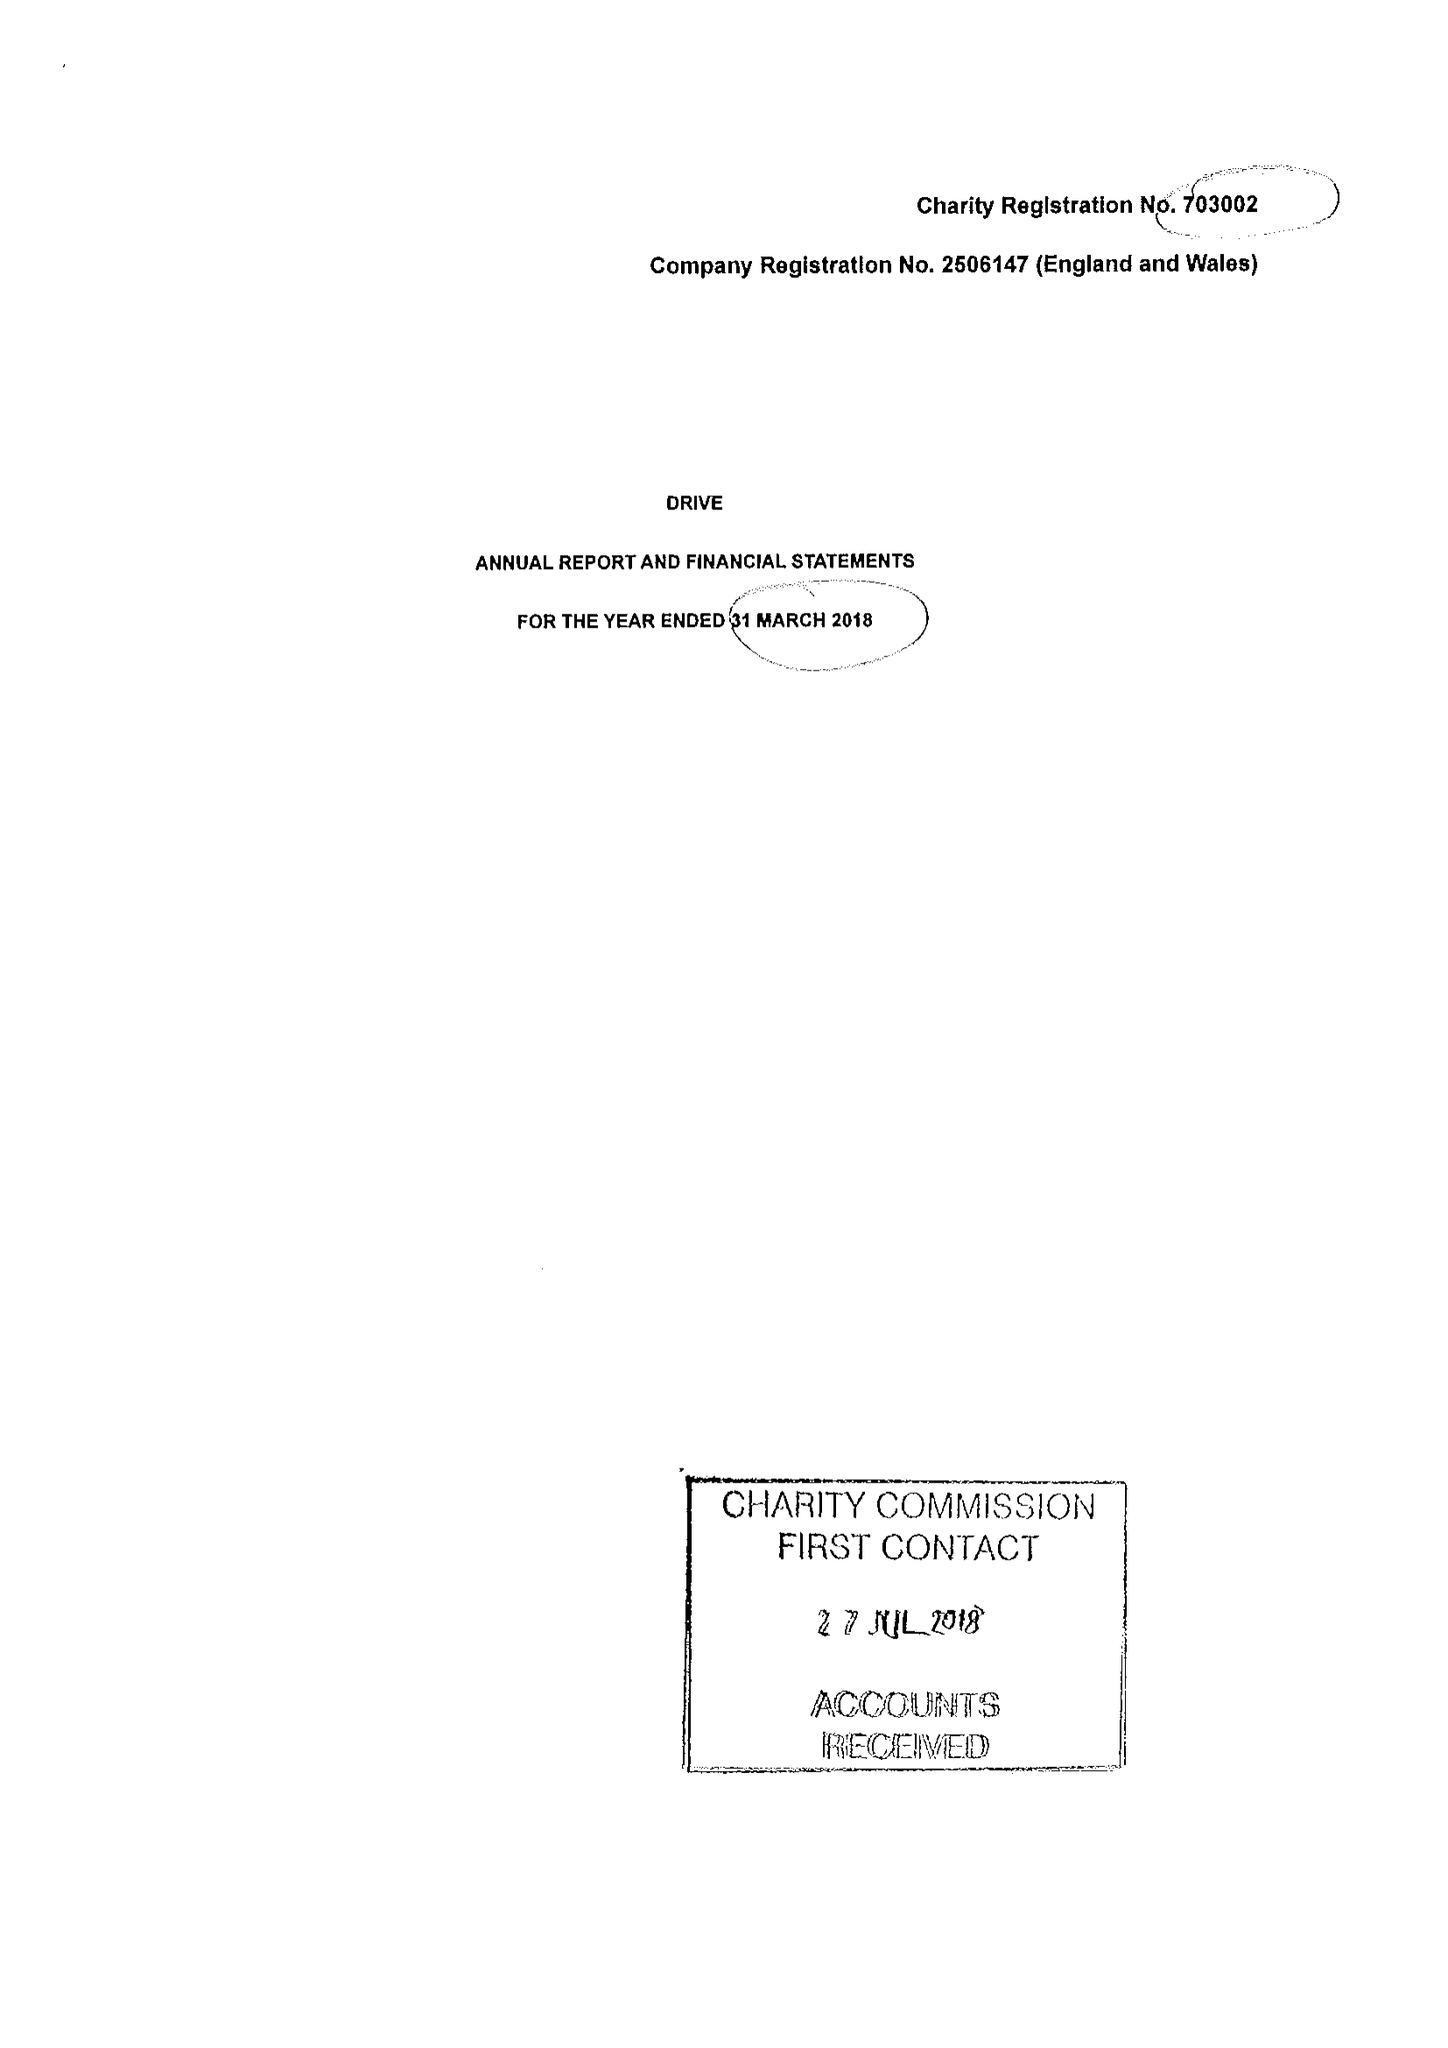What is the value for the address__post_town?
Answer the question using a single word or phrase. None 